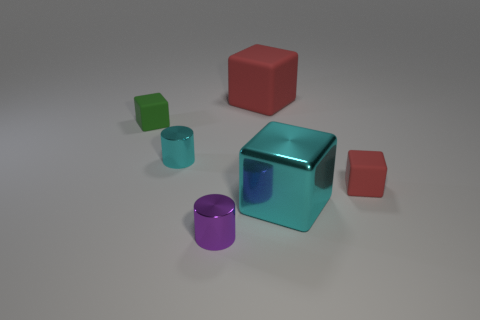What material is the big block in front of the small metallic cylinder left of the purple thing made of?
Your response must be concise. Metal. Is the number of large blocks that are to the left of the cyan cube the same as the number of small purple things?
Keep it short and to the point. Yes. What is the color of the other big rubber object that is the same shape as the green object?
Your answer should be very brief. Red. How many tiny green objects have the same shape as the big red object?
Offer a terse response. 1. There is a small object that is the same color as the large matte block; what material is it?
Your answer should be very brief. Rubber. What number of metallic cylinders are there?
Your response must be concise. 2. Are there any yellow cylinders that have the same material as the purple object?
Offer a terse response. No. What size is the cylinder that is the same color as the metal cube?
Give a very brief answer. Small. Do the metal cylinder that is behind the tiny red matte cube and the red rubber object in front of the large red matte object have the same size?
Provide a short and direct response. Yes. What size is the matte object that is in front of the small green rubber thing?
Make the answer very short. Small. 